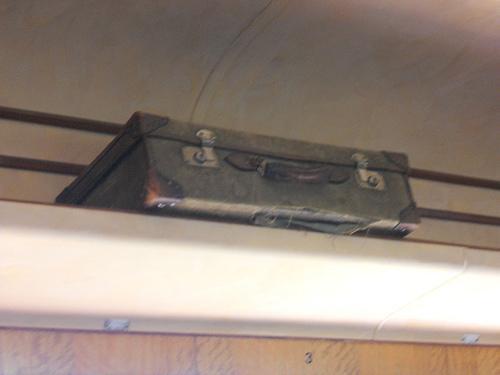How many items are there?
Give a very brief answer. 1. How many people are there?
Give a very brief answer. 0. 